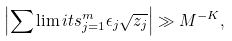Convert formula to latex. <formula><loc_0><loc_0><loc_500><loc_500>\left | \sum \lim i t s _ { j = 1 } ^ { m } \epsilon _ { j } \sqrt { z _ { j } } \right | \gg M ^ { - K } ,</formula> 